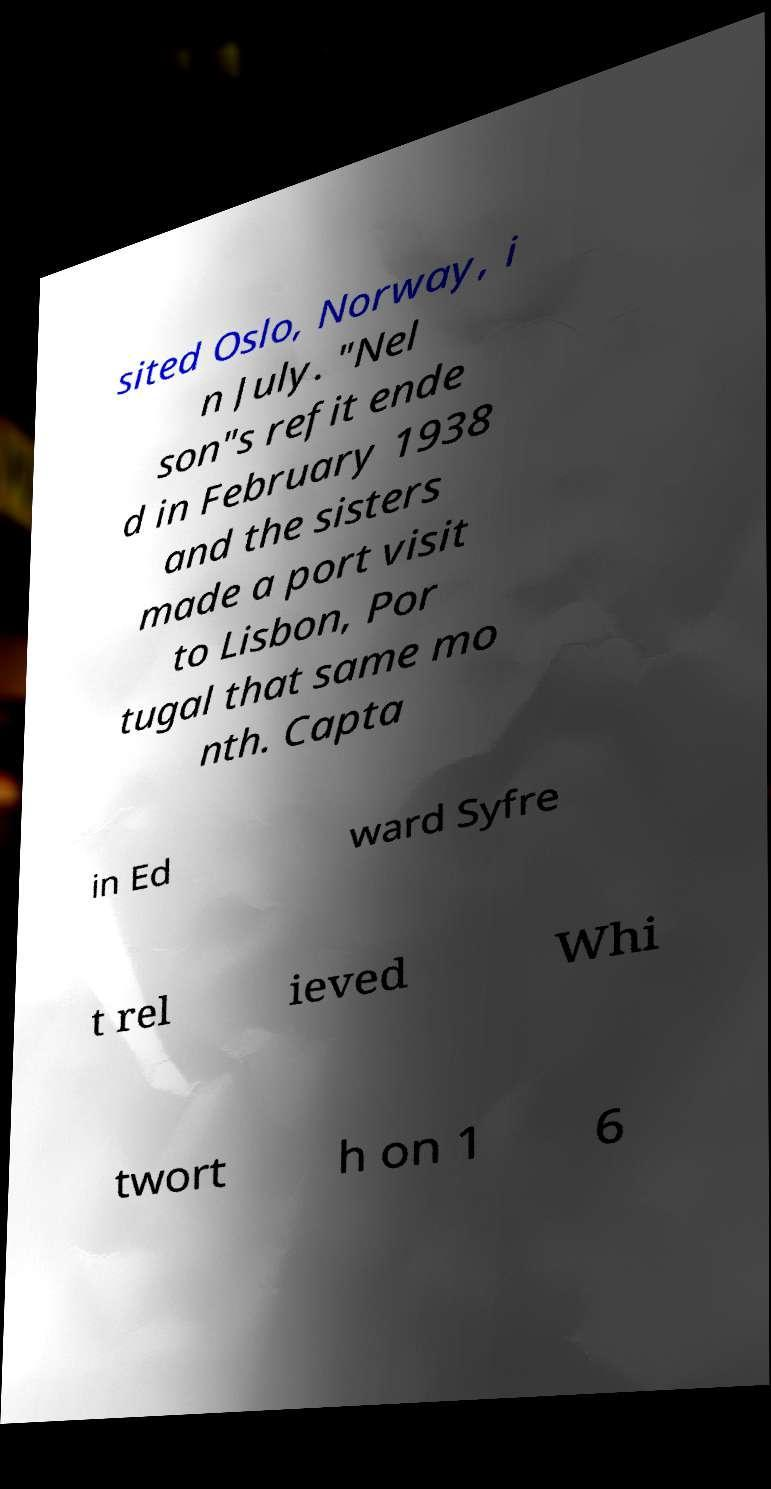Please read and relay the text visible in this image. What does it say? sited Oslo, Norway, i n July. "Nel son"s refit ende d in February 1938 and the sisters made a port visit to Lisbon, Por tugal that same mo nth. Capta in Ed ward Syfre t rel ieved Whi twort h on 1 6 